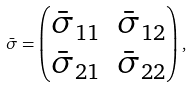<formula> <loc_0><loc_0><loc_500><loc_500>\bar { \sigma } = \begin{pmatrix} \bar { \sigma } _ { 1 1 } & \bar { \sigma } _ { 1 2 } \\ \bar { \sigma } _ { 2 1 } & \bar { \sigma } _ { 2 2 } \end{pmatrix} ,</formula> 